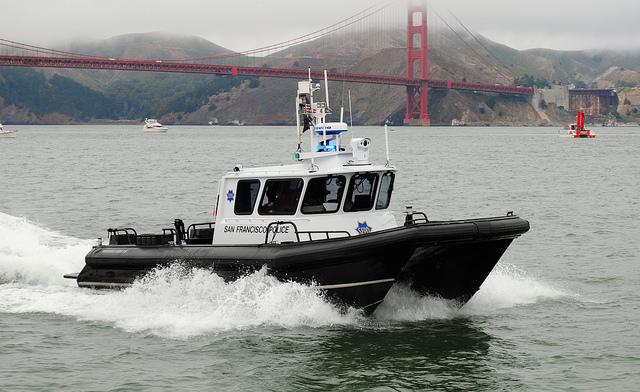What color is the body of this police boat? black 